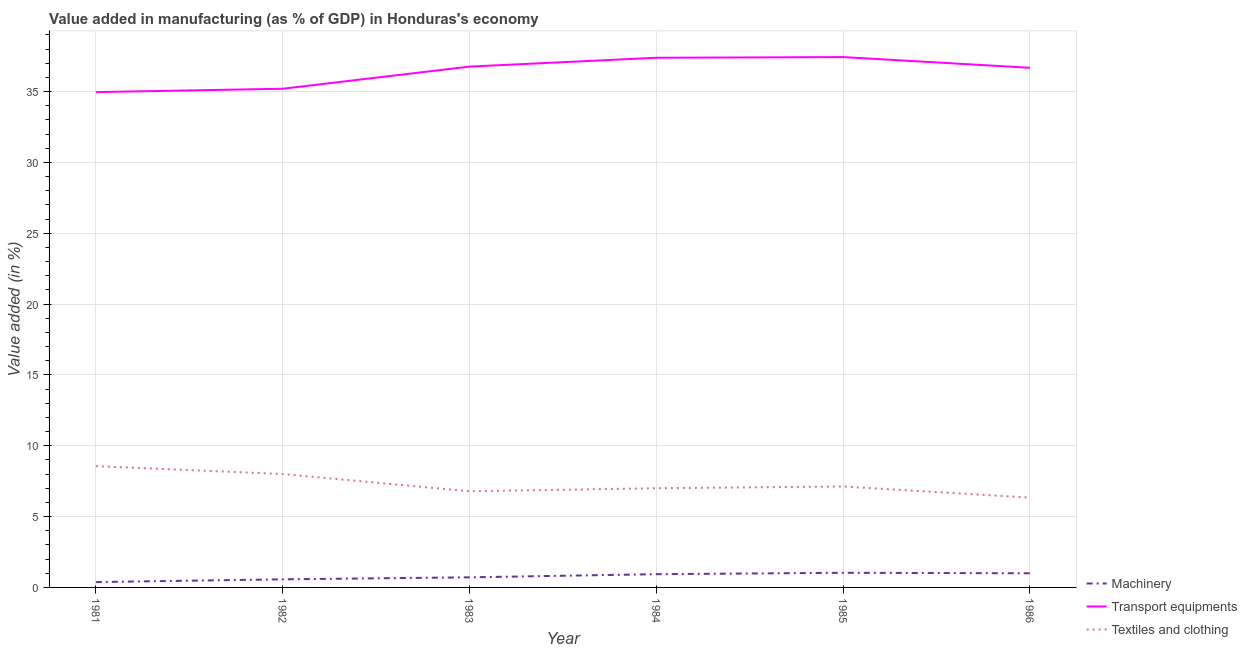How many different coloured lines are there?
Make the answer very short. 3. Does the line corresponding to value added in manufacturing textile and clothing intersect with the line corresponding to value added in manufacturing transport equipments?
Your answer should be very brief. No. What is the value added in manufacturing textile and clothing in 1981?
Offer a terse response. 8.56. Across all years, what is the maximum value added in manufacturing textile and clothing?
Your answer should be compact. 8.56. Across all years, what is the minimum value added in manufacturing machinery?
Give a very brief answer. 0.38. What is the total value added in manufacturing transport equipments in the graph?
Provide a succinct answer. 218.46. What is the difference between the value added in manufacturing transport equipments in 1981 and that in 1985?
Your answer should be very brief. -2.47. What is the difference between the value added in manufacturing machinery in 1981 and the value added in manufacturing textile and clothing in 1985?
Keep it short and to the point. -6.75. What is the average value added in manufacturing machinery per year?
Provide a short and direct response. 0.77. In the year 1982, what is the difference between the value added in manufacturing textile and clothing and value added in manufacturing transport equipments?
Your response must be concise. -27.2. What is the ratio of the value added in manufacturing transport equipments in 1981 to that in 1986?
Provide a succinct answer. 0.95. Is the value added in manufacturing machinery in 1981 less than that in 1983?
Provide a short and direct response. Yes. Is the difference between the value added in manufacturing transport equipments in 1982 and 1985 greater than the difference between the value added in manufacturing textile and clothing in 1982 and 1985?
Provide a short and direct response. No. What is the difference between the highest and the second highest value added in manufacturing transport equipments?
Your answer should be very brief. 0.05. What is the difference between the highest and the lowest value added in manufacturing textile and clothing?
Your answer should be compact. 2.22. Is it the case that in every year, the sum of the value added in manufacturing machinery and value added in manufacturing transport equipments is greater than the value added in manufacturing textile and clothing?
Ensure brevity in your answer.  Yes. Does the value added in manufacturing textile and clothing monotonically increase over the years?
Your answer should be compact. No. Is the value added in manufacturing transport equipments strictly greater than the value added in manufacturing machinery over the years?
Ensure brevity in your answer.  Yes. How many years are there in the graph?
Your answer should be very brief. 6. Are the values on the major ticks of Y-axis written in scientific E-notation?
Make the answer very short. No. Where does the legend appear in the graph?
Your response must be concise. Bottom right. What is the title of the graph?
Make the answer very short. Value added in manufacturing (as % of GDP) in Honduras's economy. What is the label or title of the X-axis?
Your answer should be very brief. Year. What is the label or title of the Y-axis?
Ensure brevity in your answer.  Value added (in %). What is the Value added (in %) of Machinery in 1981?
Provide a short and direct response. 0.38. What is the Value added (in %) in Transport equipments in 1981?
Provide a short and direct response. 34.97. What is the Value added (in %) of Textiles and clothing in 1981?
Ensure brevity in your answer.  8.56. What is the Value added (in %) of Machinery in 1982?
Keep it short and to the point. 0.57. What is the Value added (in %) of Transport equipments in 1982?
Your answer should be compact. 35.21. What is the Value added (in %) of Textiles and clothing in 1982?
Provide a short and direct response. 8.01. What is the Value added (in %) of Machinery in 1983?
Provide a succinct answer. 0.71. What is the Value added (in %) of Transport equipments in 1983?
Provide a short and direct response. 36.77. What is the Value added (in %) of Textiles and clothing in 1983?
Your answer should be compact. 6.79. What is the Value added (in %) of Machinery in 1984?
Your response must be concise. 0.93. What is the Value added (in %) of Transport equipments in 1984?
Your answer should be compact. 37.39. What is the Value added (in %) of Textiles and clothing in 1984?
Provide a short and direct response. 7. What is the Value added (in %) of Machinery in 1985?
Make the answer very short. 1.03. What is the Value added (in %) of Transport equipments in 1985?
Make the answer very short. 37.44. What is the Value added (in %) of Textiles and clothing in 1985?
Your response must be concise. 7.12. What is the Value added (in %) in Machinery in 1986?
Give a very brief answer. 1. What is the Value added (in %) in Transport equipments in 1986?
Your response must be concise. 36.68. What is the Value added (in %) of Textiles and clothing in 1986?
Your answer should be compact. 6.34. Across all years, what is the maximum Value added (in %) in Machinery?
Offer a terse response. 1.03. Across all years, what is the maximum Value added (in %) of Transport equipments?
Offer a very short reply. 37.44. Across all years, what is the maximum Value added (in %) of Textiles and clothing?
Make the answer very short. 8.56. Across all years, what is the minimum Value added (in %) in Machinery?
Provide a short and direct response. 0.38. Across all years, what is the minimum Value added (in %) in Transport equipments?
Provide a short and direct response. 34.97. Across all years, what is the minimum Value added (in %) in Textiles and clothing?
Ensure brevity in your answer.  6.34. What is the total Value added (in %) in Machinery in the graph?
Your response must be concise. 4.63. What is the total Value added (in %) of Transport equipments in the graph?
Keep it short and to the point. 218.46. What is the total Value added (in %) of Textiles and clothing in the graph?
Your answer should be compact. 43.82. What is the difference between the Value added (in %) of Machinery in 1981 and that in 1982?
Make the answer very short. -0.19. What is the difference between the Value added (in %) in Transport equipments in 1981 and that in 1982?
Provide a succinct answer. -0.24. What is the difference between the Value added (in %) of Textiles and clothing in 1981 and that in 1982?
Your response must be concise. 0.56. What is the difference between the Value added (in %) in Machinery in 1981 and that in 1983?
Keep it short and to the point. -0.34. What is the difference between the Value added (in %) in Transport equipments in 1981 and that in 1983?
Provide a short and direct response. -1.8. What is the difference between the Value added (in %) of Textiles and clothing in 1981 and that in 1983?
Ensure brevity in your answer.  1.77. What is the difference between the Value added (in %) in Machinery in 1981 and that in 1984?
Offer a terse response. -0.56. What is the difference between the Value added (in %) in Transport equipments in 1981 and that in 1984?
Give a very brief answer. -2.42. What is the difference between the Value added (in %) in Textiles and clothing in 1981 and that in 1984?
Your response must be concise. 1.56. What is the difference between the Value added (in %) in Machinery in 1981 and that in 1985?
Make the answer very short. -0.66. What is the difference between the Value added (in %) in Transport equipments in 1981 and that in 1985?
Your answer should be compact. -2.47. What is the difference between the Value added (in %) of Textiles and clothing in 1981 and that in 1985?
Make the answer very short. 1.44. What is the difference between the Value added (in %) in Machinery in 1981 and that in 1986?
Give a very brief answer. -0.62. What is the difference between the Value added (in %) in Transport equipments in 1981 and that in 1986?
Keep it short and to the point. -1.72. What is the difference between the Value added (in %) in Textiles and clothing in 1981 and that in 1986?
Keep it short and to the point. 2.22. What is the difference between the Value added (in %) in Machinery in 1982 and that in 1983?
Make the answer very short. -0.14. What is the difference between the Value added (in %) of Transport equipments in 1982 and that in 1983?
Ensure brevity in your answer.  -1.56. What is the difference between the Value added (in %) in Textiles and clothing in 1982 and that in 1983?
Offer a very short reply. 1.22. What is the difference between the Value added (in %) in Machinery in 1982 and that in 1984?
Make the answer very short. -0.36. What is the difference between the Value added (in %) in Transport equipments in 1982 and that in 1984?
Your response must be concise. -2.19. What is the difference between the Value added (in %) of Textiles and clothing in 1982 and that in 1984?
Provide a short and direct response. 1. What is the difference between the Value added (in %) in Machinery in 1982 and that in 1985?
Make the answer very short. -0.46. What is the difference between the Value added (in %) in Transport equipments in 1982 and that in 1985?
Ensure brevity in your answer.  -2.24. What is the difference between the Value added (in %) in Textiles and clothing in 1982 and that in 1985?
Keep it short and to the point. 0.88. What is the difference between the Value added (in %) in Machinery in 1982 and that in 1986?
Provide a short and direct response. -0.43. What is the difference between the Value added (in %) of Transport equipments in 1982 and that in 1986?
Offer a terse response. -1.48. What is the difference between the Value added (in %) of Textiles and clothing in 1982 and that in 1986?
Provide a succinct answer. 1.67. What is the difference between the Value added (in %) of Machinery in 1983 and that in 1984?
Provide a short and direct response. -0.22. What is the difference between the Value added (in %) of Transport equipments in 1983 and that in 1984?
Provide a succinct answer. -0.62. What is the difference between the Value added (in %) in Textiles and clothing in 1983 and that in 1984?
Your answer should be very brief. -0.21. What is the difference between the Value added (in %) of Machinery in 1983 and that in 1985?
Ensure brevity in your answer.  -0.32. What is the difference between the Value added (in %) of Transport equipments in 1983 and that in 1985?
Offer a terse response. -0.67. What is the difference between the Value added (in %) in Textiles and clothing in 1983 and that in 1985?
Ensure brevity in your answer.  -0.34. What is the difference between the Value added (in %) in Machinery in 1983 and that in 1986?
Make the answer very short. -0.28. What is the difference between the Value added (in %) of Transport equipments in 1983 and that in 1986?
Offer a very short reply. 0.08. What is the difference between the Value added (in %) in Textiles and clothing in 1983 and that in 1986?
Provide a short and direct response. 0.45. What is the difference between the Value added (in %) of Machinery in 1984 and that in 1985?
Your answer should be very brief. -0.1. What is the difference between the Value added (in %) of Transport equipments in 1984 and that in 1985?
Ensure brevity in your answer.  -0.05. What is the difference between the Value added (in %) of Textiles and clothing in 1984 and that in 1985?
Offer a terse response. -0.12. What is the difference between the Value added (in %) of Machinery in 1984 and that in 1986?
Offer a very short reply. -0.06. What is the difference between the Value added (in %) of Transport equipments in 1984 and that in 1986?
Your response must be concise. 0.71. What is the difference between the Value added (in %) of Textiles and clothing in 1984 and that in 1986?
Ensure brevity in your answer.  0.66. What is the difference between the Value added (in %) in Machinery in 1985 and that in 1986?
Ensure brevity in your answer.  0.04. What is the difference between the Value added (in %) in Transport equipments in 1985 and that in 1986?
Ensure brevity in your answer.  0.76. What is the difference between the Value added (in %) of Textiles and clothing in 1985 and that in 1986?
Offer a very short reply. 0.78. What is the difference between the Value added (in %) of Machinery in 1981 and the Value added (in %) of Transport equipments in 1982?
Provide a succinct answer. -34.83. What is the difference between the Value added (in %) of Machinery in 1981 and the Value added (in %) of Textiles and clothing in 1982?
Provide a short and direct response. -7.63. What is the difference between the Value added (in %) in Transport equipments in 1981 and the Value added (in %) in Textiles and clothing in 1982?
Provide a short and direct response. 26.96. What is the difference between the Value added (in %) of Machinery in 1981 and the Value added (in %) of Transport equipments in 1983?
Your answer should be compact. -36.39. What is the difference between the Value added (in %) in Machinery in 1981 and the Value added (in %) in Textiles and clothing in 1983?
Make the answer very short. -6.41. What is the difference between the Value added (in %) in Transport equipments in 1981 and the Value added (in %) in Textiles and clothing in 1983?
Provide a short and direct response. 28.18. What is the difference between the Value added (in %) in Machinery in 1981 and the Value added (in %) in Transport equipments in 1984?
Provide a short and direct response. -37.01. What is the difference between the Value added (in %) in Machinery in 1981 and the Value added (in %) in Textiles and clothing in 1984?
Give a very brief answer. -6.62. What is the difference between the Value added (in %) of Transport equipments in 1981 and the Value added (in %) of Textiles and clothing in 1984?
Provide a short and direct response. 27.97. What is the difference between the Value added (in %) in Machinery in 1981 and the Value added (in %) in Transport equipments in 1985?
Offer a terse response. -37.06. What is the difference between the Value added (in %) of Machinery in 1981 and the Value added (in %) of Textiles and clothing in 1985?
Offer a very short reply. -6.75. What is the difference between the Value added (in %) in Transport equipments in 1981 and the Value added (in %) in Textiles and clothing in 1985?
Provide a succinct answer. 27.84. What is the difference between the Value added (in %) in Machinery in 1981 and the Value added (in %) in Transport equipments in 1986?
Ensure brevity in your answer.  -36.31. What is the difference between the Value added (in %) of Machinery in 1981 and the Value added (in %) of Textiles and clothing in 1986?
Your answer should be compact. -5.96. What is the difference between the Value added (in %) in Transport equipments in 1981 and the Value added (in %) in Textiles and clothing in 1986?
Give a very brief answer. 28.63. What is the difference between the Value added (in %) of Machinery in 1982 and the Value added (in %) of Transport equipments in 1983?
Provide a short and direct response. -36.2. What is the difference between the Value added (in %) in Machinery in 1982 and the Value added (in %) in Textiles and clothing in 1983?
Make the answer very short. -6.22. What is the difference between the Value added (in %) of Transport equipments in 1982 and the Value added (in %) of Textiles and clothing in 1983?
Your answer should be compact. 28.42. What is the difference between the Value added (in %) in Machinery in 1982 and the Value added (in %) in Transport equipments in 1984?
Keep it short and to the point. -36.82. What is the difference between the Value added (in %) in Machinery in 1982 and the Value added (in %) in Textiles and clothing in 1984?
Offer a terse response. -6.43. What is the difference between the Value added (in %) of Transport equipments in 1982 and the Value added (in %) of Textiles and clothing in 1984?
Give a very brief answer. 28.2. What is the difference between the Value added (in %) in Machinery in 1982 and the Value added (in %) in Transport equipments in 1985?
Your answer should be compact. -36.87. What is the difference between the Value added (in %) in Machinery in 1982 and the Value added (in %) in Textiles and clothing in 1985?
Give a very brief answer. -6.55. What is the difference between the Value added (in %) of Transport equipments in 1982 and the Value added (in %) of Textiles and clothing in 1985?
Offer a terse response. 28.08. What is the difference between the Value added (in %) in Machinery in 1982 and the Value added (in %) in Transport equipments in 1986?
Provide a succinct answer. -36.11. What is the difference between the Value added (in %) in Machinery in 1982 and the Value added (in %) in Textiles and clothing in 1986?
Your answer should be very brief. -5.77. What is the difference between the Value added (in %) in Transport equipments in 1982 and the Value added (in %) in Textiles and clothing in 1986?
Your answer should be compact. 28.86. What is the difference between the Value added (in %) of Machinery in 1983 and the Value added (in %) of Transport equipments in 1984?
Keep it short and to the point. -36.68. What is the difference between the Value added (in %) of Machinery in 1983 and the Value added (in %) of Textiles and clothing in 1984?
Your response must be concise. -6.29. What is the difference between the Value added (in %) of Transport equipments in 1983 and the Value added (in %) of Textiles and clothing in 1984?
Provide a short and direct response. 29.77. What is the difference between the Value added (in %) in Machinery in 1983 and the Value added (in %) in Transport equipments in 1985?
Keep it short and to the point. -36.73. What is the difference between the Value added (in %) of Machinery in 1983 and the Value added (in %) of Textiles and clothing in 1985?
Offer a very short reply. -6.41. What is the difference between the Value added (in %) in Transport equipments in 1983 and the Value added (in %) in Textiles and clothing in 1985?
Your response must be concise. 29.64. What is the difference between the Value added (in %) in Machinery in 1983 and the Value added (in %) in Transport equipments in 1986?
Your response must be concise. -35.97. What is the difference between the Value added (in %) in Machinery in 1983 and the Value added (in %) in Textiles and clothing in 1986?
Make the answer very short. -5.63. What is the difference between the Value added (in %) in Transport equipments in 1983 and the Value added (in %) in Textiles and clothing in 1986?
Offer a terse response. 30.43. What is the difference between the Value added (in %) of Machinery in 1984 and the Value added (in %) of Transport equipments in 1985?
Keep it short and to the point. -36.51. What is the difference between the Value added (in %) in Machinery in 1984 and the Value added (in %) in Textiles and clothing in 1985?
Make the answer very short. -6.19. What is the difference between the Value added (in %) of Transport equipments in 1984 and the Value added (in %) of Textiles and clothing in 1985?
Offer a very short reply. 30.27. What is the difference between the Value added (in %) in Machinery in 1984 and the Value added (in %) in Transport equipments in 1986?
Your answer should be compact. -35.75. What is the difference between the Value added (in %) in Machinery in 1984 and the Value added (in %) in Textiles and clothing in 1986?
Offer a very short reply. -5.41. What is the difference between the Value added (in %) of Transport equipments in 1984 and the Value added (in %) of Textiles and clothing in 1986?
Offer a terse response. 31.05. What is the difference between the Value added (in %) in Machinery in 1985 and the Value added (in %) in Transport equipments in 1986?
Offer a terse response. -35.65. What is the difference between the Value added (in %) in Machinery in 1985 and the Value added (in %) in Textiles and clothing in 1986?
Provide a succinct answer. -5.31. What is the difference between the Value added (in %) of Transport equipments in 1985 and the Value added (in %) of Textiles and clothing in 1986?
Your answer should be compact. 31.1. What is the average Value added (in %) in Machinery per year?
Provide a succinct answer. 0.77. What is the average Value added (in %) in Transport equipments per year?
Give a very brief answer. 36.41. What is the average Value added (in %) of Textiles and clothing per year?
Keep it short and to the point. 7.3. In the year 1981, what is the difference between the Value added (in %) in Machinery and Value added (in %) in Transport equipments?
Your response must be concise. -34.59. In the year 1981, what is the difference between the Value added (in %) of Machinery and Value added (in %) of Textiles and clothing?
Offer a terse response. -8.18. In the year 1981, what is the difference between the Value added (in %) of Transport equipments and Value added (in %) of Textiles and clothing?
Provide a succinct answer. 26.41. In the year 1982, what is the difference between the Value added (in %) of Machinery and Value added (in %) of Transport equipments?
Offer a terse response. -34.63. In the year 1982, what is the difference between the Value added (in %) in Machinery and Value added (in %) in Textiles and clothing?
Offer a terse response. -7.43. In the year 1982, what is the difference between the Value added (in %) of Transport equipments and Value added (in %) of Textiles and clothing?
Ensure brevity in your answer.  27.2. In the year 1983, what is the difference between the Value added (in %) in Machinery and Value added (in %) in Transport equipments?
Your answer should be very brief. -36.06. In the year 1983, what is the difference between the Value added (in %) of Machinery and Value added (in %) of Textiles and clothing?
Keep it short and to the point. -6.08. In the year 1983, what is the difference between the Value added (in %) of Transport equipments and Value added (in %) of Textiles and clothing?
Ensure brevity in your answer.  29.98. In the year 1984, what is the difference between the Value added (in %) in Machinery and Value added (in %) in Transport equipments?
Your answer should be very brief. -36.46. In the year 1984, what is the difference between the Value added (in %) in Machinery and Value added (in %) in Textiles and clothing?
Ensure brevity in your answer.  -6.07. In the year 1984, what is the difference between the Value added (in %) of Transport equipments and Value added (in %) of Textiles and clothing?
Your response must be concise. 30.39. In the year 1985, what is the difference between the Value added (in %) in Machinery and Value added (in %) in Transport equipments?
Ensure brevity in your answer.  -36.41. In the year 1985, what is the difference between the Value added (in %) of Machinery and Value added (in %) of Textiles and clothing?
Your answer should be very brief. -6.09. In the year 1985, what is the difference between the Value added (in %) in Transport equipments and Value added (in %) in Textiles and clothing?
Provide a succinct answer. 30.32. In the year 1986, what is the difference between the Value added (in %) of Machinery and Value added (in %) of Transport equipments?
Provide a succinct answer. -35.69. In the year 1986, what is the difference between the Value added (in %) of Machinery and Value added (in %) of Textiles and clothing?
Keep it short and to the point. -5.34. In the year 1986, what is the difference between the Value added (in %) of Transport equipments and Value added (in %) of Textiles and clothing?
Make the answer very short. 30.34. What is the ratio of the Value added (in %) in Machinery in 1981 to that in 1982?
Give a very brief answer. 0.66. What is the ratio of the Value added (in %) in Textiles and clothing in 1981 to that in 1982?
Provide a succinct answer. 1.07. What is the ratio of the Value added (in %) of Machinery in 1981 to that in 1983?
Your answer should be very brief. 0.53. What is the ratio of the Value added (in %) of Transport equipments in 1981 to that in 1983?
Your answer should be very brief. 0.95. What is the ratio of the Value added (in %) in Textiles and clothing in 1981 to that in 1983?
Provide a short and direct response. 1.26. What is the ratio of the Value added (in %) of Machinery in 1981 to that in 1984?
Provide a short and direct response. 0.4. What is the ratio of the Value added (in %) of Transport equipments in 1981 to that in 1984?
Offer a very short reply. 0.94. What is the ratio of the Value added (in %) in Textiles and clothing in 1981 to that in 1984?
Keep it short and to the point. 1.22. What is the ratio of the Value added (in %) in Machinery in 1981 to that in 1985?
Ensure brevity in your answer.  0.37. What is the ratio of the Value added (in %) of Transport equipments in 1981 to that in 1985?
Offer a terse response. 0.93. What is the ratio of the Value added (in %) in Textiles and clothing in 1981 to that in 1985?
Your answer should be compact. 1.2. What is the ratio of the Value added (in %) of Machinery in 1981 to that in 1986?
Keep it short and to the point. 0.38. What is the ratio of the Value added (in %) of Transport equipments in 1981 to that in 1986?
Your response must be concise. 0.95. What is the ratio of the Value added (in %) of Textiles and clothing in 1981 to that in 1986?
Offer a terse response. 1.35. What is the ratio of the Value added (in %) of Machinery in 1982 to that in 1983?
Provide a succinct answer. 0.8. What is the ratio of the Value added (in %) in Transport equipments in 1982 to that in 1983?
Your response must be concise. 0.96. What is the ratio of the Value added (in %) of Textiles and clothing in 1982 to that in 1983?
Provide a succinct answer. 1.18. What is the ratio of the Value added (in %) in Machinery in 1982 to that in 1984?
Offer a terse response. 0.61. What is the ratio of the Value added (in %) in Transport equipments in 1982 to that in 1984?
Your answer should be compact. 0.94. What is the ratio of the Value added (in %) in Textiles and clothing in 1982 to that in 1984?
Ensure brevity in your answer.  1.14. What is the ratio of the Value added (in %) of Machinery in 1982 to that in 1985?
Make the answer very short. 0.55. What is the ratio of the Value added (in %) of Transport equipments in 1982 to that in 1985?
Ensure brevity in your answer.  0.94. What is the ratio of the Value added (in %) in Textiles and clothing in 1982 to that in 1985?
Ensure brevity in your answer.  1.12. What is the ratio of the Value added (in %) of Machinery in 1982 to that in 1986?
Offer a terse response. 0.57. What is the ratio of the Value added (in %) of Transport equipments in 1982 to that in 1986?
Your answer should be very brief. 0.96. What is the ratio of the Value added (in %) of Textiles and clothing in 1982 to that in 1986?
Your response must be concise. 1.26. What is the ratio of the Value added (in %) of Machinery in 1983 to that in 1984?
Provide a short and direct response. 0.76. What is the ratio of the Value added (in %) in Transport equipments in 1983 to that in 1984?
Ensure brevity in your answer.  0.98. What is the ratio of the Value added (in %) of Textiles and clothing in 1983 to that in 1984?
Offer a very short reply. 0.97. What is the ratio of the Value added (in %) of Machinery in 1983 to that in 1985?
Your answer should be very brief. 0.69. What is the ratio of the Value added (in %) in Textiles and clothing in 1983 to that in 1985?
Ensure brevity in your answer.  0.95. What is the ratio of the Value added (in %) of Machinery in 1983 to that in 1986?
Ensure brevity in your answer.  0.71. What is the ratio of the Value added (in %) of Transport equipments in 1983 to that in 1986?
Keep it short and to the point. 1. What is the ratio of the Value added (in %) in Textiles and clothing in 1983 to that in 1986?
Your answer should be compact. 1.07. What is the ratio of the Value added (in %) in Machinery in 1984 to that in 1985?
Your answer should be compact. 0.91. What is the ratio of the Value added (in %) of Textiles and clothing in 1984 to that in 1985?
Ensure brevity in your answer.  0.98. What is the ratio of the Value added (in %) of Machinery in 1984 to that in 1986?
Ensure brevity in your answer.  0.94. What is the ratio of the Value added (in %) in Transport equipments in 1984 to that in 1986?
Ensure brevity in your answer.  1.02. What is the ratio of the Value added (in %) of Textiles and clothing in 1984 to that in 1986?
Offer a terse response. 1.1. What is the ratio of the Value added (in %) of Machinery in 1985 to that in 1986?
Your answer should be compact. 1.04. What is the ratio of the Value added (in %) of Transport equipments in 1985 to that in 1986?
Make the answer very short. 1.02. What is the ratio of the Value added (in %) of Textiles and clothing in 1985 to that in 1986?
Ensure brevity in your answer.  1.12. What is the difference between the highest and the second highest Value added (in %) in Machinery?
Give a very brief answer. 0.04. What is the difference between the highest and the second highest Value added (in %) of Transport equipments?
Offer a terse response. 0.05. What is the difference between the highest and the second highest Value added (in %) in Textiles and clothing?
Give a very brief answer. 0.56. What is the difference between the highest and the lowest Value added (in %) of Machinery?
Your answer should be compact. 0.66. What is the difference between the highest and the lowest Value added (in %) of Transport equipments?
Give a very brief answer. 2.47. What is the difference between the highest and the lowest Value added (in %) in Textiles and clothing?
Ensure brevity in your answer.  2.22. 